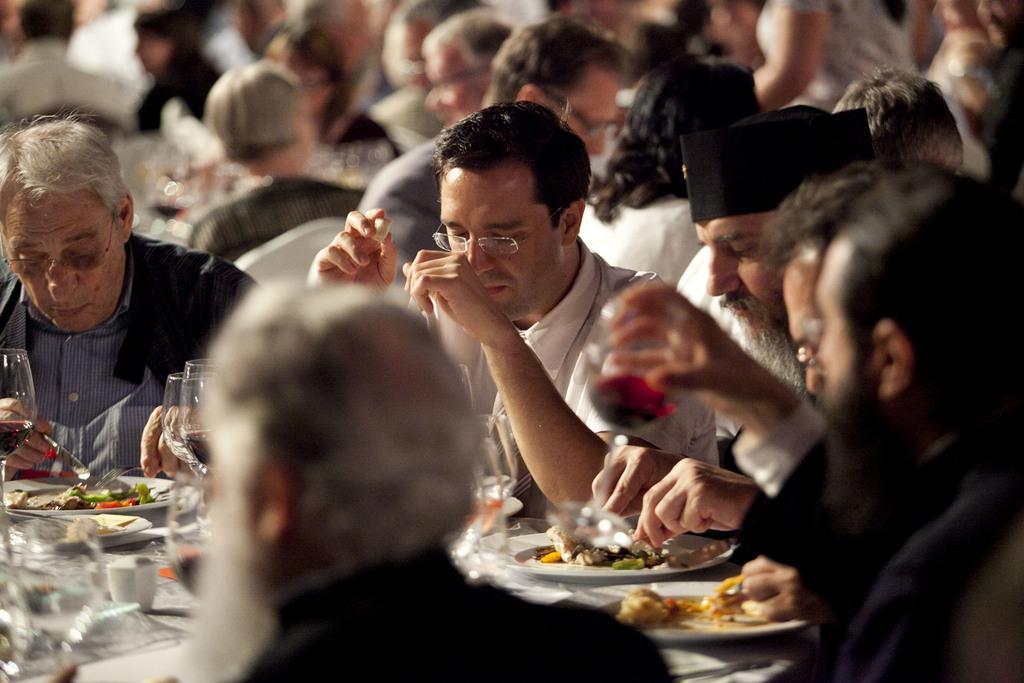In one or two sentences, can you explain what this image depicts? In this picture I can see many peoples who are sitting near to the table. On the table I can see the plates, glasses, foil papers, vegetable, bread, bottle and other items. At the top I can see many people who are sitting on the chair near to the table. 